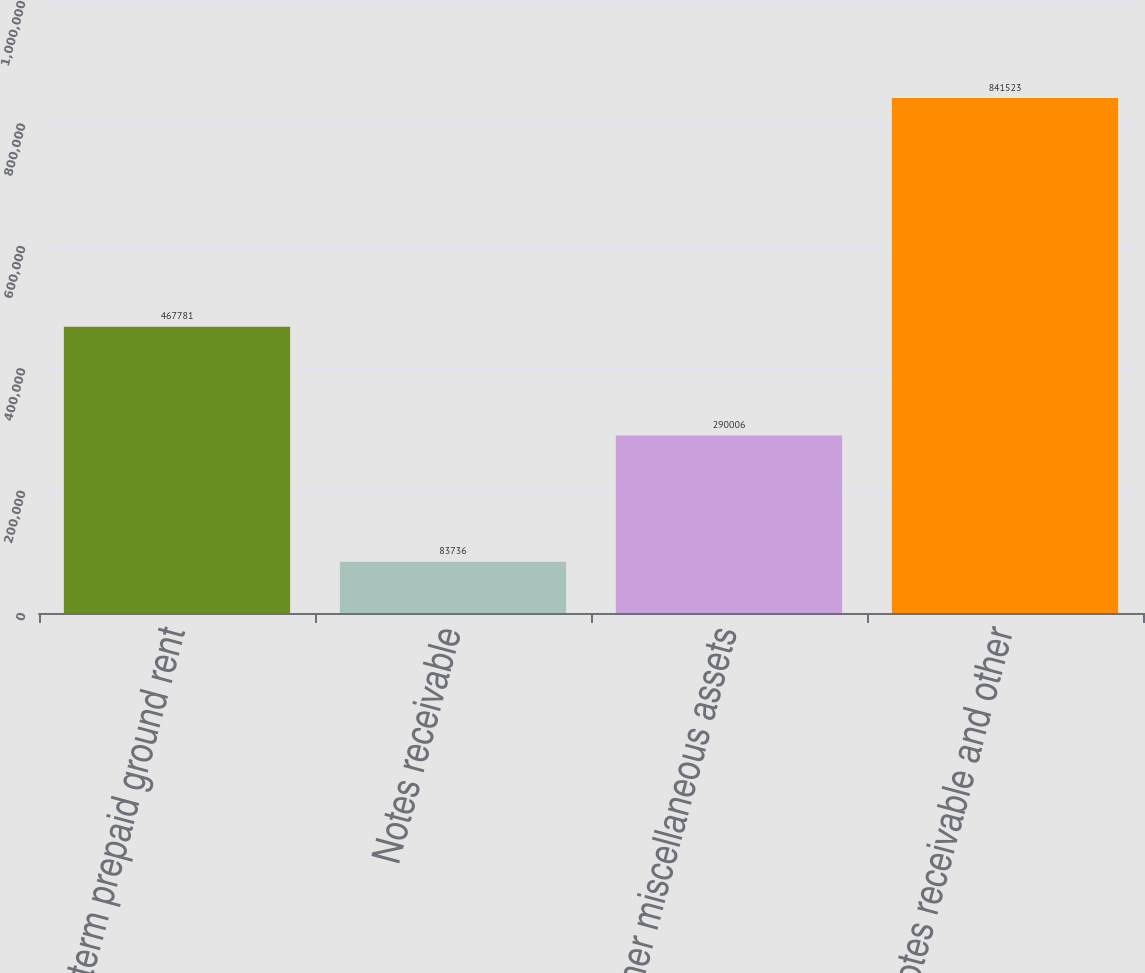<chart> <loc_0><loc_0><loc_500><loc_500><bar_chart><fcel>Long-term prepaid ground rent<fcel>Notes receivable<fcel>Other miscellaneous assets<fcel>Notes receivable and other<nl><fcel>467781<fcel>83736<fcel>290006<fcel>841523<nl></chart> 